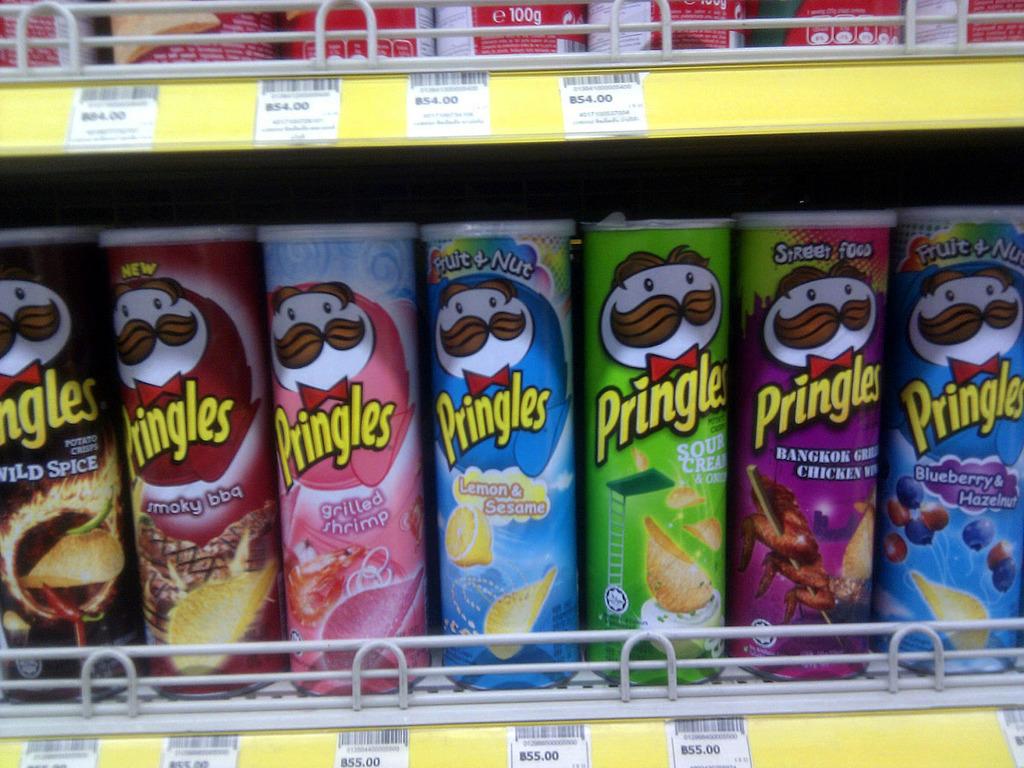What brand is being sold here?
Your answer should be compact. Pringles. What flavor is in the middle in blue?
Offer a very short reply. Lemon & sesame. 